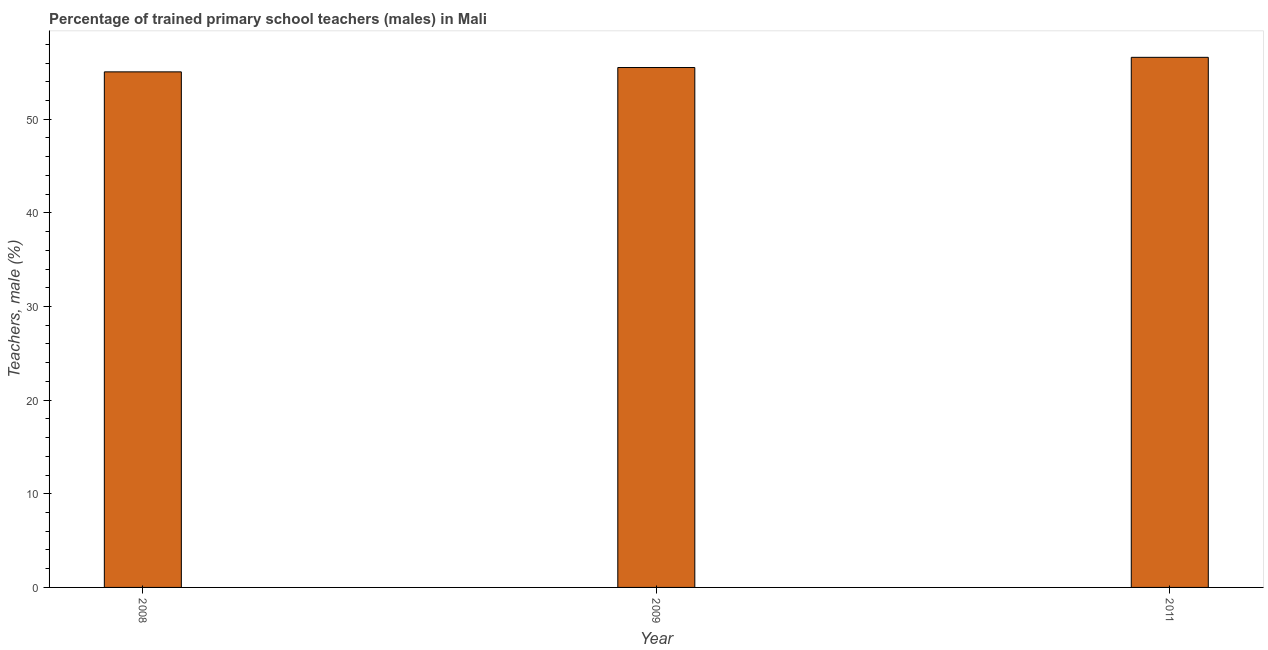Does the graph contain any zero values?
Make the answer very short. No. What is the title of the graph?
Your answer should be compact. Percentage of trained primary school teachers (males) in Mali. What is the label or title of the Y-axis?
Provide a short and direct response. Teachers, male (%). What is the percentage of trained male teachers in 2008?
Keep it short and to the point. 55.05. Across all years, what is the maximum percentage of trained male teachers?
Keep it short and to the point. 56.61. Across all years, what is the minimum percentage of trained male teachers?
Provide a succinct answer. 55.05. In which year was the percentage of trained male teachers minimum?
Provide a short and direct response. 2008. What is the sum of the percentage of trained male teachers?
Your answer should be compact. 167.18. What is the difference between the percentage of trained male teachers in 2008 and 2009?
Offer a very short reply. -0.46. What is the average percentage of trained male teachers per year?
Ensure brevity in your answer.  55.73. What is the median percentage of trained male teachers?
Provide a short and direct response. 55.52. What is the ratio of the percentage of trained male teachers in 2008 to that in 2009?
Offer a very short reply. 0.99. Is the difference between the percentage of trained male teachers in 2009 and 2011 greater than the difference between any two years?
Offer a terse response. No. What is the difference between the highest and the second highest percentage of trained male teachers?
Offer a very short reply. 1.09. What is the difference between the highest and the lowest percentage of trained male teachers?
Ensure brevity in your answer.  1.55. How many bars are there?
Give a very brief answer. 3. Are all the bars in the graph horizontal?
Provide a succinct answer. No. What is the difference between two consecutive major ticks on the Y-axis?
Your answer should be very brief. 10. Are the values on the major ticks of Y-axis written in scientific E-notation?
Offer a very short reply. No. What is the Teachers, male (%) of 2008?
Your answer should be compact. 55.05. What is the Teachers, male (%) of 2009?
Keep it short and to the point. 55.52. What is the Teachers, male (%) of 2011?
Keep it short and to the point. 56.61. What is the difference between the Teachers, male (%) in 2008 and 2009?
Provide a short and direct response. -0.46. What is the difference between the Teachers, male (%) in 2008 and 2011?
Provide a short and direct response. -1.55. What is the difference between the Teachers, male (%) in 2009 and 2011?
Provide a succinct answer. -1.09. What is the ratio of the Teachers, male (%) in 2008 to that in 2011?
Keep it short and to the point. 0.97. 